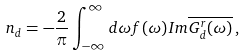<formula> <loc_0><loc_0><loc_500><loc_500>n _ { d } = - \frac { 2 } { \pi } \int _ { - \infty } ^ { \infty } d \omega f ( \omega ) I m \overline { G ^ { r } _ { d } ( \omega ) } \, ,</formula> 